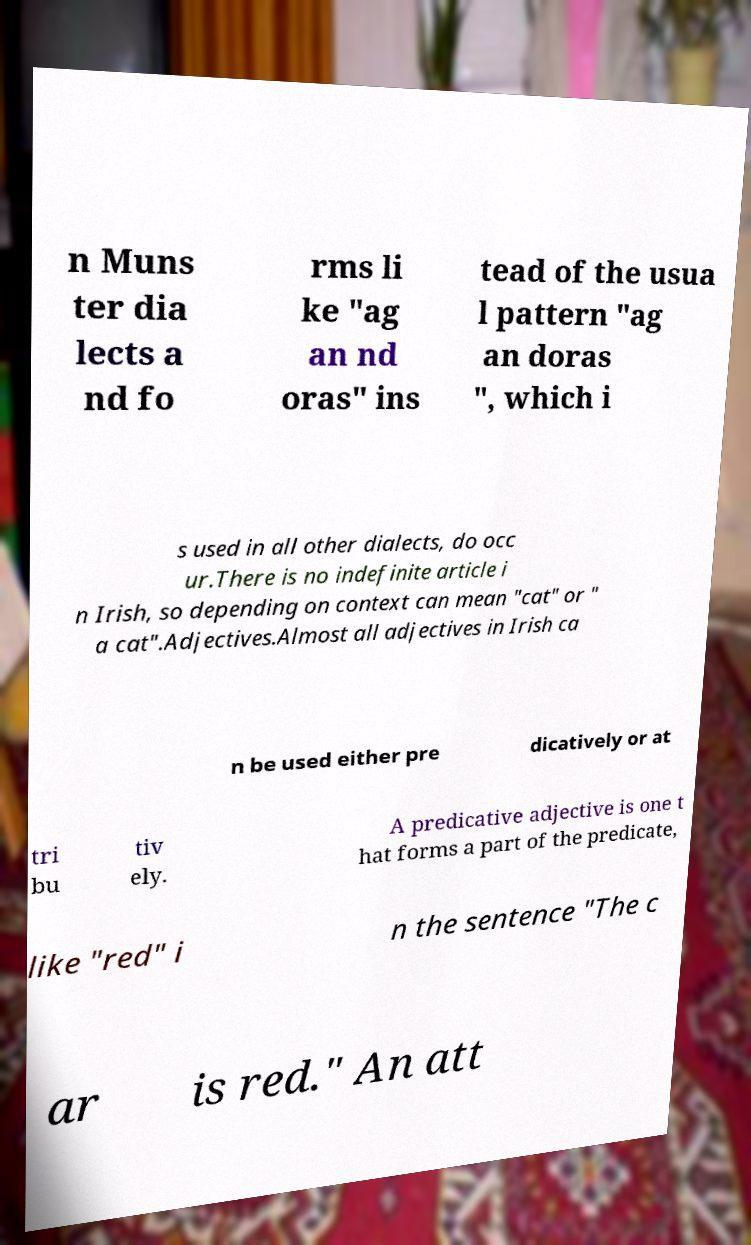Could you assist in decoding the text presented in this image and type it out clearly? n Muns ter dia lects a nd fo rms li ke "ag an nd oras" ins tead of the usua l pattern "ag an doras ", which i s used in all other dialects, do occ ur.There is no indefinite article i n Irish, so depending on context can mean "cat" or " a cat".Adjectives.Almost all adjectives in Irish ca n be used either pre dicatively or at tri bu tiv ely. A predicative adjective is one t hat forms a part of the predicate, like "red" i n the sentence "The c ar is red." An att 